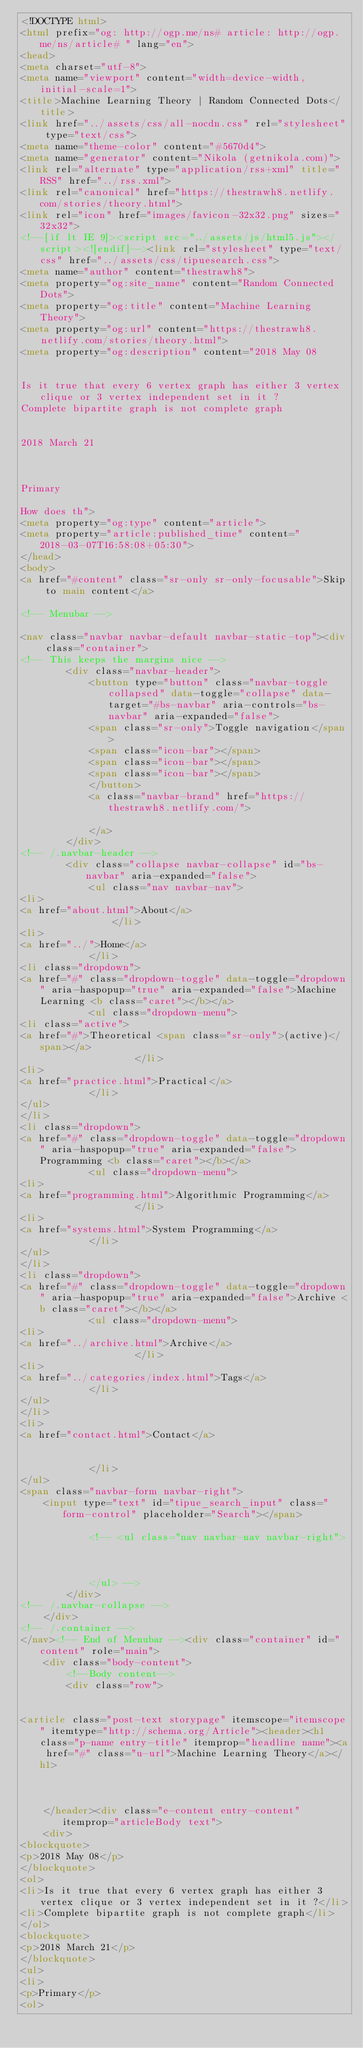<code> <loc_0><loc_0><loc_500><loc_500><_HTML_><!DOCTYPE html>
<html prefix="og: http://ogp.me/ns# article: http://ogp.me/ns/article# " lang="en">
<head>
<meta charset="utf-8">
<meta name="viewport" content="width=device-width, initial-scale=1">
<title>Machine Learning Theory | Random Connected Dots</title>
<link href="../assets/css/all-nocdn.css" rel="stylesheet" type="text/css">
<meta name="theme-color" content="#5670d4">
<meta name="generator" content="Nikola (getnikola.com)">
<link rel="alternate" type="application/rss+xml" title="RSS" href="../rss.xml">
<link rel="canonical" href="https://thestrawh8.netlify.com/stories/theory.html">
<link rel="icon" href="images/favicon-32x32.png" sizes="32x32">
<!--[if lt IE 9]><script src="../assets/js/html5.js"></script><![endif]--><link rel="stylesheet" type="text/css" href="../assets/css/tipuesearch.css">
<meta name="author" content="thestrawh8">
<meta property="og:site_name" content="Random Connected Dots">
<meta property="og:title" content="Machine Learning Theory">
<meta property="og:url" content="https://thestrawh8.netlify.com/stories/theory.html">
<meta property="og:description" content="2018 May 08


Is it true that every 6 vertex graph has either 3 vertex clique or 3 vertex independent set in it ?
Complete bipartite graph is not complete graph


2018 March 21



Primary

How does th">
<meta property="og:type" content="article">
<meta property="article:published_time" content="2018-03-07T16:58:08+05:30">
</head>
<body>
<a href="#content" class="sr-only sr-only-focusable">Skip to main content</a>

<!-- Menubar -->

<nav class="navbar navbar-default navbar-static-top"><div class="container">
<!-- This keeps the margins nice -->
        <div class="navbar-header">
            <button type="button" class="navbar-toggle collapsed" data-toggle="collapse" data-target="#bs-navbar" aria-controls="bs-navbar" aria-expanded="false">
            <span class="sr-only">Toggle navigation</span>
            <span class="icon-bar"></span>
            <span class="icon-bar"></span>
            <span class="icon-bar"></span>
            </button>
            <a class="navbar-brand" href="https://thestrawh8.netlify.com/">

            </a>
        </div>
<!-- /.navbar-header -->
        <div class="collapse navbar-collapse" id="bs-navbar" aria-expanded="false">
            <ul class="nav navbar-nav">
<li>
<a href="about.html">About</a>
                </li>
<li>
<a href="../">Home</a>
            </li>
<li class="dropdown">
<a href="#" class="dropdown-toggle" data-toggle="dropdown" aria-haspopup="true" aria-expanded="false">Machine Learning <b class="caret"></b></a>
            <ul class="dropdown-menu">
<li class="active">
<a href="#">Theoretical <span class="sr-only">(active)</span></a>
                    </li>
<li>
<a href="practice.html">Practical</a>
            </li>
</ul>
</li>
<li class="dropdown">
<a href="#" class="dropdown-toggle" data-toggle="dropdown" aria-haspopup="true" aria-expanded="false">Programming <b class="caret"></b></a>
            <ul class="dropdown-menu">
<li>
<a href="programming.html">Algorithmic Programming</a>
                    </li>
<li>
<a href="systems.html">System Programming</a>
            </li>
</ul>
</li>
<li class="dropdown">
<a href="#" class="dropdown-toggle" data-toggle="dropdown" aria-haspopup="true" aria-expanded="false">Archive <b class="caret"></b></a>
            <ul class="dropdown-menu">
<li>
<a href="../archive.html">Archive</a>
                    </li>
<li>
<a href="../categories/index.html">Tags</a>
            </li>
</ul>
</li>
<li>
<a href="contact.html">Contact</a>

                
            </li>
</ul>
<span class="navbar-form navbar-right">
    <input type="text" id="tipue_search_input" class="form-control" placeholder="Search"></span>

            <!-- <ul class="nav navbar-nav navbar-right">
                
                
                
            </ul> -->
        </div>
<!-- /.navbar-collapse -->
    </div>
<!-- /.container -->
</nav><!-- End of Menubar --><div class="container" id="content" role="main">
    <div class="body-content">
        <!--Body content-->
        <div class="row">
            
            
<article class="post-text storypage" itemscope="itemscope" itemtype="http://schema.org/Article"><header><h1 class="p-name entry-title" itemprop="headline name"><a href="#" class="u-url">Machine Learning Theory</a></h1>

        

    </header><div class="e-content entry-content" itemprop="articleBody text">
    <div>
<blockquote>
<p>2018 May 08</p>
</blockquote>
<ol>
<li>Is it true that every 6 vertex graph has either 3 vertex clique or 3 vertex independent set in it ?</li>
<li>Complete bipartite graph is not complete graph</li>
</ol>
<blockquote>
<p>2018 March 21</p>
</blockquote>
<ul>
<li>
<p>Primary</p>
<ol></code> 